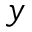Convert formula to latex. <formula><loc_0><loc_0><loc_500><loc_500>y</formula> 